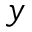Convert formula to latex. <formula><loc_0><loc_0><loc_500><loc_500>y</formula> 